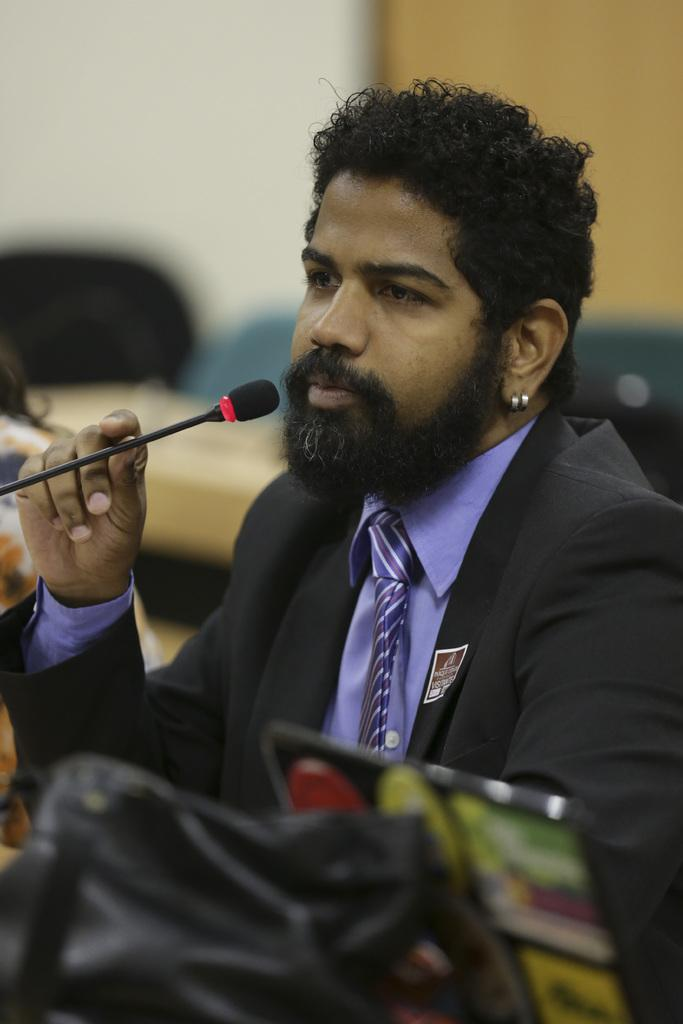Who is the main subject in the image? There is a man in the image. What is the man holding in the image? The man is holding a microphone. Can you describe the background of the image? The background of the image is blurry. Are there any mice visible in the image? No, there are no mice present in the image. Is there any smoke coming from the microphone in the image? No, there is no smoke visible in the image. 